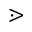Convert formula to latex. <formula><loc_0><loc_0><loc_500><loc_500>\gtrdot</formula> 